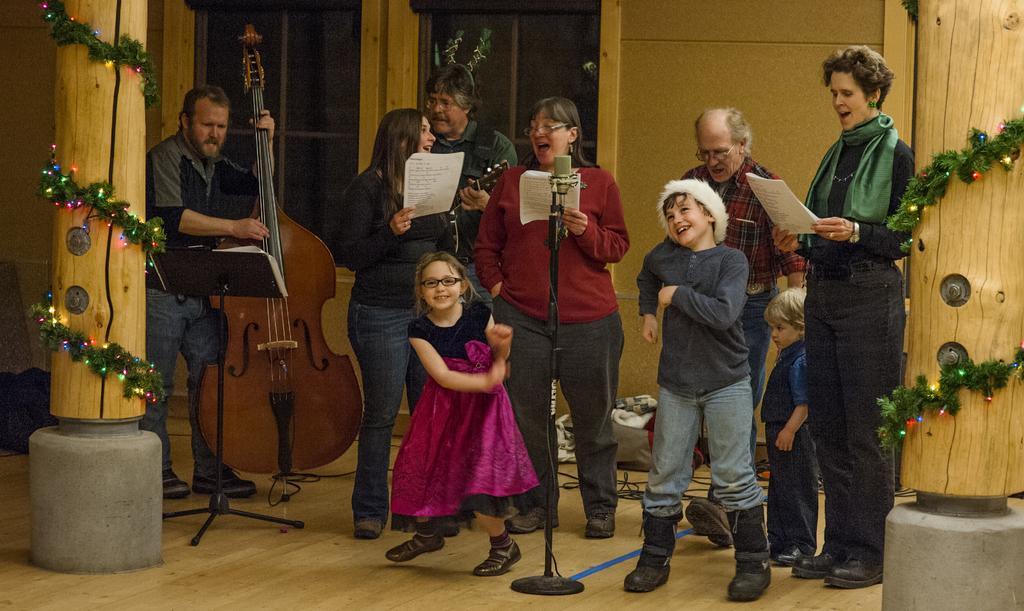In one or two sentences, can you explain what this image depicts? In the center of the picture we can see group of people. Towards left we can see pillar, light, decorative items, stand, paper and a person playing a musical instrument. In the middle of the picture we can see kids dancing. In the background we can see a person playing a musical instrument. In the background there are windows and wall. At the bottom there are cables and floor. On the right there is a pillar, light and decoration items. 